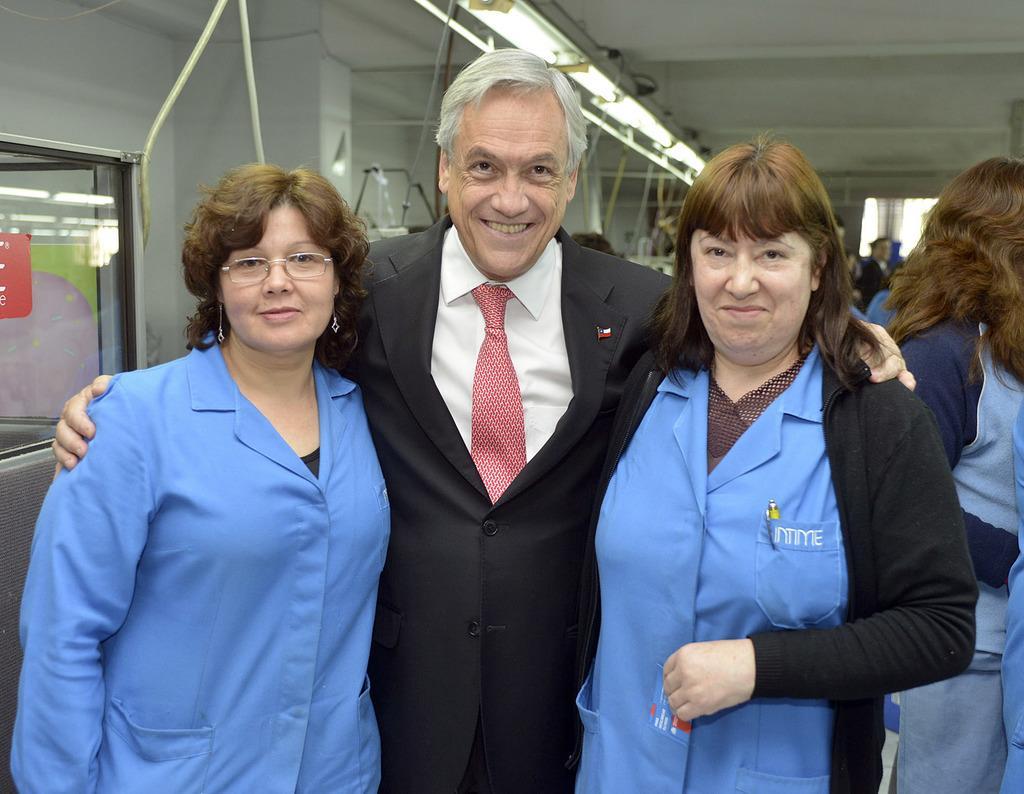Describe this image in one or two sentences. In the image there is an old man in black suit standing in the middle of two women in blue apron, behind them there are many people standing and there are lights on the ceiling. 